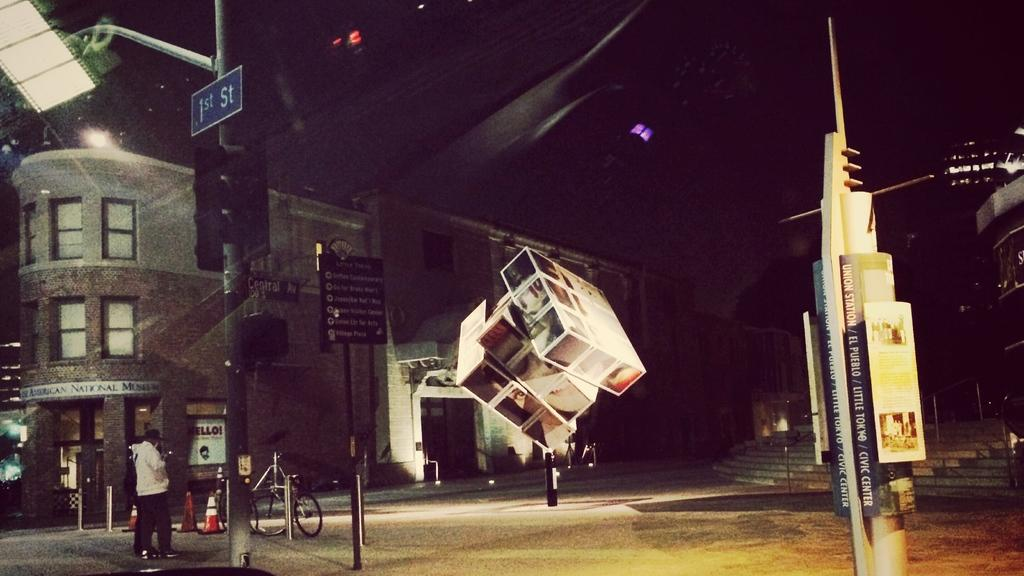What is on the signal light pole in the image? There is a signboard on a signal light pole in the image. What else can be seen in the image besides the signboard? There are hoardings, buildings, steps, traffic cones, and a person in the background. Can you describe the buildings in the background? The buildings in the background are not described in the provided facts, so we cannot provide more information about them. What is the purpose of the traffic cones in the image? The purpose of the traffic cones in the image is not mentioned in the provided facts, so we cannot determine their purpose. What type of power does the manager have over the connection in the image? There is no mention of a manager or a connection in the image, so we cannot answer this question. 